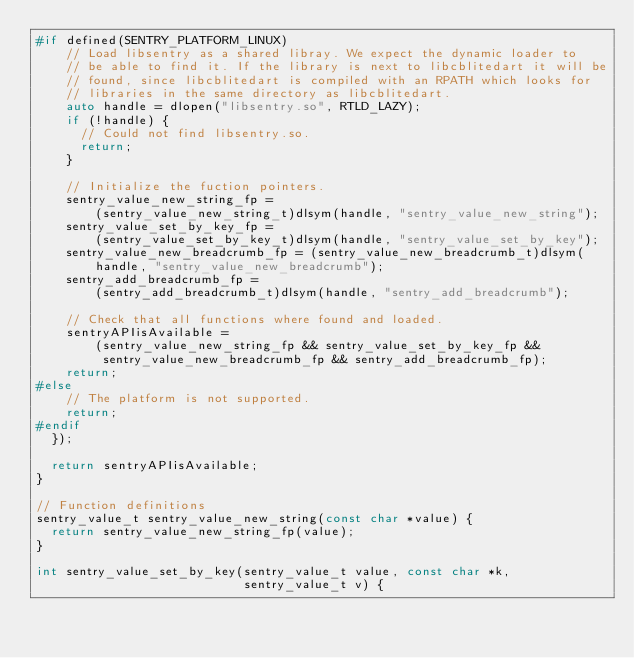Convert code to text. <code><loc_0><loc_0><loc_500><loc_500><_C++_>#if defined(SENTRY_PLATFORM_LINUX)
    // Load libsentry as a shared libray. We expect the dynamic loader to
    // be able to find it. If the library is next to libcblitedart it will be
    // found, since libcblitedart is compiled with an RPATH which looks for
    // libraries in the same directory as libcblitedart.
    auto handle = dlopen("libsentry.so", RTLD_LAZY);
    if (!handle) {
      // Could not find libsentry.so.
      return;
    }

    // Initialize the fuction pointers.
    sentry_value_new_string_fp =
        (sentry_value_new_string_t)dlsym(handle, "sentry_value_new_string");
    sentry_value_set_by_key_fp =
        (sentry_value_set_by_key_t)dlsym(handle, "sentry_value_set_by_key");
    sentry_value_new_breadcrumb_fp = (sentry_value_new_breadcrumb_t)dlsym(
        handle, "sentry_value_new_breadcrumb");
    sentry_add_breadcrumb_fp =
        (sentry_add_breadcrumb_t)dlsym(handle, "sentry_add_breadcrumb");

    // Check that all functions where found and loaded.
    sentryAPIisAvailable =
        (sentry_value_new_string_fp && sentry_value_set_by_key_fp &&
         sentry_value_new_breadcrumb_fp && sentry_add_breadcrumb_fp);
    return;
#else
    // The platform is not supported.
    return;
#endif
  });

  return sentryAPIisAvailable;
}

// Function definitions
sentry_value_t sentry_value_new_string(const char *value) {
  return sentry_value_new_string_fp(value);
}

int sentry_value_set_by_key(sentry_value_t value, const char *k,
                            sentry_value_t v) {</code> 